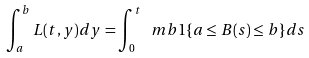Convert formula to latex. <formula><loc_0><loc_0><loc_500><loc_500>\int _ { a } ^ { b } L ( t , y ) d y = \int _ { 0 } ^ { t } \ m b 1 \{ a \leq B ( s ) \leq b \} d s</formula> 